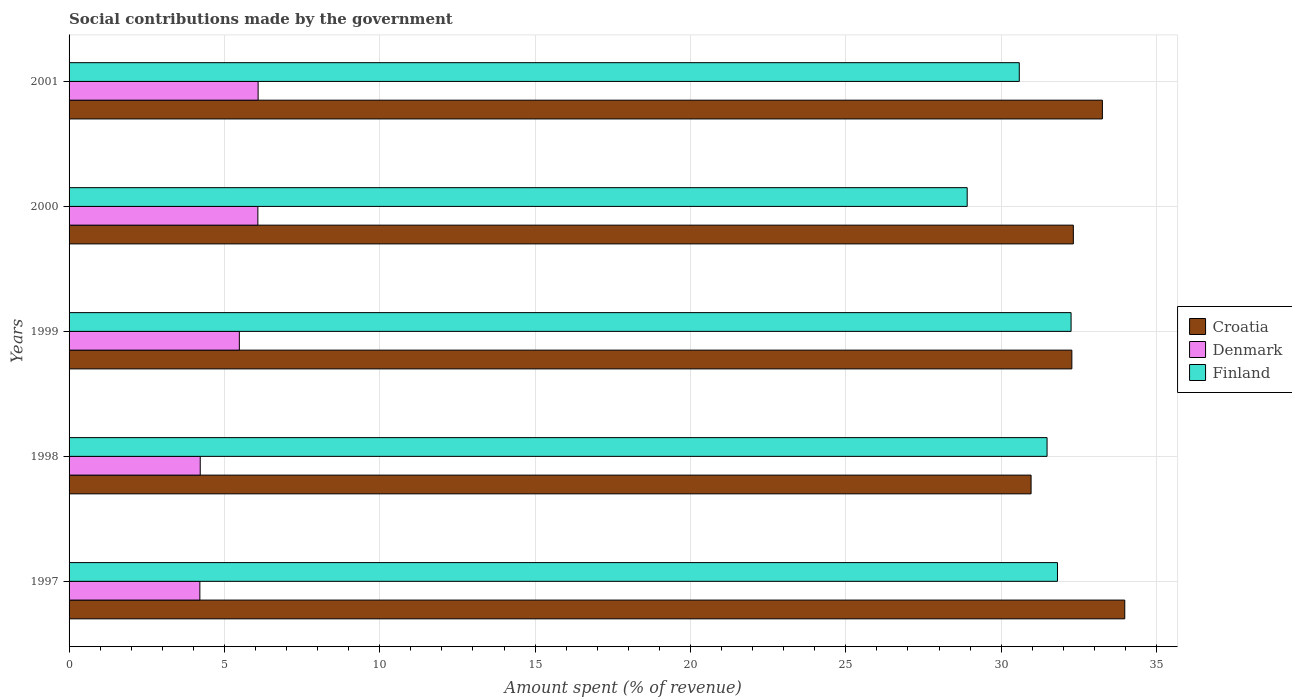How many different coloured bars are there?
Provide a short and direct response. 3. Are the number of bars on each tick of the Y-axis equal?
Give a very brief answer. Yes. How many bars are there on the 4th tick from the top?
Your answer should be very brief. 3. How many bars are there on the 2nd tick from the bottom?
Offer a very short reply. 3. What is the amount spent (in %) on social contributions in Croatia in 1999?
Give a very brief answer. 32.27. Across all years, what is the maximum amount spent (in %) on social contributions in Denmark?
Make the answer very short. 6.08. Across all years, what is the minimum amount spent (in %) on social contributions in Denmark?
Your answer should be compact. 4.21. In which year was the amount spent (in %) on social contributions in Croatia minimum?
Your answer should be compact. 1998. What is the total amount spent (in %) on social contributions in Denmark in the graph?
Ensure brevity in your answer.  26.07. What is the difference between the amount spent (in %) on social contributions in Croatia in 1997 and that in 2000?
Your answer should be compact. 1.66. What is the difference between the amount spent (in %) on social contributions in Croatia in 2000 and the amount spent (in %) on social contributions in Denmark in 1997?
Offer a very short reply. 28.11. What is the average amount spent (in %) on social contributions in Finland per year?
Provide a short and direct response. 31. In the year 1998, what is the difference between the amount spent (in %) on social contributions in Croatia and amount spent (in %) on social contributions in Finland?
Keep it short and to the point. -0.51. In how many years, is the amount spent (in %) on social contributions in Denmark greater than 7 %?
Your response must be concise. 0. What is the ratio of the amount spent (in %) on social contributions in Denmark in 1998 to that in 2001?
Offer a terse response. 0.69. Is the difference between the amount spent (in %) on social contributions in Croatia in 1997 and 2001 greater than the difference between the amount spent (in %) on social contributions in Finland in 1997 and 2001?
Provide a succinct answer. No. What is the difference between the highest and the second highest amount spent (in %) on social contributions in Denmark?
Your answer should be very brief. 0.01. What is the difference between the highest and the lowest amount spent (in %) on social contributions in Croatia?
Provide a succinct answer. 3.02. In how many years, is the amount spent (in %) on social contributions in Croatia greater than the average amount spent (in %) on social contributions in Croatia taken over all years?
Your response must be concise. 2. What does the 2nd bar from the top in 2000 represents?
Your answer should be compact. Denmark. What does the 1st bar from the bottom in 1997 represents?
Ensure brevity in your answer.  Croatia. How many bars are there?
Your response must be concise. 15. How many years are there in the graph?
Offer a terse response. 5. What is the difference between two consecutive major ticks on the X-axis?
Offer a terse response. 5. Are the values on the major ticks of X-axis written in scientific E-notation?
Provide a short and direct response. No. Does the graph contain any zero values?
Your answer should be very brief. No. How many legend labels are there?
Provide a succinct answer. 3. How are the legend labels stacked?
Your response must be concise. Vertical. What is the title of the graph?
Keep it short and to the point. Social contributions made by the government. What is the label or title of the X-axis?
Provide a succinct answer. Amount spent (% of revenue). What is the label or title of the Y-axis?
Provide a short and direct response. Years. What is the Amount spent (% of revenue) in Croatia in 1997?
Offer a very short reply. 33.98. What is the Amount spent (% of revenue) in Denmark in 1997?
Offer a terse response. 4.21. What is the Amount spent (% of revenue) in Finland in 1997?
Your answer should be compact. 31.81. What is the Amount spent (% of revenue) of Croatia in 1998?
Provide a short and direct response. 30.96. What is the Amount spent (% of revenue) in Denmark in 1998?
Your answer should be very brief. 4.22. What is the Amount spent (% of revenue) in Finland in 1998?
Ensure brevity in your answer.  31.48. What is the Amount spent (% of revenue) of Croatia in 1999?
Keep it short and to the point. 32.27. What is the Amount spent (% of revenue) of Denmark in 1999?
Give a very brief answer. 5.48. What is the Amount spent (% of revenue) of Finland in 1999?
Give a very brief answer. 32.25. What is the Amount spent (% of revenue) of Croatia in 2000?
Your answer should be compact. 32.32. What is the Amount spent (% of revenue) of Denmark in 2000?
Your answer should be compact. 6.08. What is the Amount spent (% of revenue) of Finland in 2000?
Your response must be concise. 28.91. What is the Amount spent (% of revenue) of Croatia in 2001?
Keep it short and to the point. 33.26. What is the Amount spent (% of revenue) of Denmark in 2001?
Give a very brief answer. 6.08. What is the Amount spent (% of revenue) of Finland in 2001?
Keep it short and to the point. 30.58. Across all years, what is the maximum Amount spent (% of revenue) of Croatia?
Ensure brevity in your answer.  33.98. Across all years, what is the maximum Amount spent (% of revenue) of Denmark?
Offer a terse response. 6.08. Across all years, what is the maximum Amount spent (% of revenue) of Finland?
Keep it short and to the point. 32.25. Across all years, what is the minimum Amount spent (% of revenue) of Croatia?
Provide a succinct answer. 30.96. Across all years, what is the minimum Amount spent (% of revenue) of Denmark?
Give a very brief answer. 4.21. Across all years, what is the minimum Amount spent (% of revenue) in Finland?
Make the answer very short. 28.91. What is the total Amount spent (% of revenue) in Croatia in the graph?
Offer a terse response. 162.79. What is the total Amount spent (% of revenue) of Denmark in the graph?
Provide a succinct answer. 26.07. What is the total Amount spent (% of revenue) of Finland in the graph?
Provide a short and direct response. 155.02. What is the difference between the Amount spent (% of revenue) in Croatia in 1997 and that in 1998?
Provide a short and direct response. 3.02. What is the difference between the Amount spent (% of revenue) of Denmark in 1997 and that in 1998?
Give a very brief answer. -0.01. What is the difference between the Amount spent (% of revenue) of Finland in 1997 and that in 1998?
Your answer should be very brief. 0.34. What is the difference between the Amount spent (% of revenue) of Croatia in 1997 and that in 1999?
Your answer should be compact. 1.7. What is the difference between the Amount spent (% of revenue) in Denmark in 1997 and that in 1999?
Make the answer very short. -1.27. What is the difference between the Amount spent (% of revenue) of Finland in 1997 and that in 1999?
Make the answer very short. -0.44. What is the difference between the Amount spent (% of revenue) in Croatia in 1997 and that in 2000?
Your response must be concise. 1.66. What is the difference between the Amount spent (% of revenue) of Denmark in 1997 and that in 2000?
Keep it short and to the point. -1.87. What is the difference between the Amount spent (% of revenue) of Finland in 1997 and that in 2000?
Offer a terse response. 2.91. What is the difference between the Amount spent (% of revenue) in Croatia in 1997 and that in 2001?
Your answer should be very brief. 0.72. What is the difference between the Amount spent (% of revenue) of Denmark in 1997 and that in 2001?
Offer a very short reply. -1.88. What is the difference between the Amount spent (% of revenue) in Finland in 1997 and that in 2001?
Keep it short and to the point. 1.23. What is the difference between the Amount spent (% of revenue) of Croatia in 1998 and that in 1999?
Keep it short and to the point. -1.31. What is the difference between the Amount spent (% of revenue) in Denmark in 1998 and that in 1999?
Ensure brevity in your answer.  -1.26. What is the difference between the Amount spent (% of revenue) in Finland in 1998 and that in 1999?
Keep it short and to the point. -0.77. What is the difference between the Amount spent (% of revenue) in Croatia in 1998 and that in 2000?
Make the answer very short. -1.36. What is the difference between the Amount spent (% of revenue) of Denmark in 1998 and that in 2000?
Make the answer very short. -1.86. What is the difference between the Amount spent (% of revenue) in Finland in 1998 and that in 2000?
Your response must be concise. 2.57. What is the difference between the Amount spent (% of revenue) of Croatia in 1998 and that in 2001?
Give a very brief answer. -2.3. What is the difference between the Amount spent (% of revenue) of Denmark in 1998 and that in 2001?
Provide a short and direct response. -1.86. What is the difference between the Amount spent (% of revenue) of Finland in 1998 and that in 2001?
Give a very brief answer. 0.89. What is the difference between the Amount spent (% of revenue) of Croatia in 1999 and that in 2000?
Offer a very short reply. -0.05. What is the difference between the Amount spent (% of revenue) of Denmark in 1999 and that in 2000?
Give a very brief answer. -0.6. What is the difference between the Amount spent (% of revenue) in Finland in 1999 and that in 2000?
Provide a succinct answer. 3.34. What is the difference between the Amount spent (% of revenue) in Croatia in 1999 and that in 2001?
Your answer should be very brief. -0.98. What is the difference between the Amount spent (% of revenue) in Denmark in 1999 and that in 2001?
Give a very brief answer. -0.6. What is the difference between the Amount spent (% of revenue) in Finland in 1999 and that in 2001?
Offer a terse response. 1.67. What is the difference between the Amount spent (% of revenue) in Croatia in 2000 and that in 2001?
Give a very brief answer. -0.94. What is the difference between the Amount spent (% of revenue) in Denmark in 2000 and that in 2001?
Your answer should be very brief. -0.01. What is the difference between the Amount spent (% of revenue) of Finland in 2000 and that in 2001?
Your response must be concise. -1.68. What is the difference between the Amount spent (% of revenue) of Croatia in 1997 and the Amount spent (% of revenue) of Denmark in 1998?
Provide a succinct answer. 29.76. What is the difference between the Amount spent (% of revenue) in Croatia in 1997 and the Amount spent (% of revenue) in Finland in 1998?
Keep it short and to the point. 2.5. What is the difference between the Amount spent (% of revenue) in Denmark in 1997 and the Amount spent (% of revenue) in Finland in 1998?
Ensure brevity in your answer.  -27.27. What is the difference between the Amount spent (% of revenue) in Croatia in 1997 and the Amount spent (% of revenue) in Denmark in 1999?
Provide a succinct answer. 28.5. What is the difference between the Amount spent (% of revenue) in Croatia in 1997 and the Amount spent (% of revenue) in Finland in 1999?
Your response must be concise. 1.73. What is the difference between the Amount spent (% of revenue) in Denmark in 1997 and the Amount spent (% of revenue) in Finland in 1999?
Provide a short and direct response. -28.04. What is the difference between the Amount spent (% of revenue) of Croatia in 1997 and the Amount spent (% of revenue) of Denmark in 2000?
Make the answer very short. 27.9. What is the difference between the Amount spent (% of revenue) of Croatia in 1997 and the Amount spent (% of revenue) of Finland in 2000?
Your response must be concise. 5.07. What is the difference between the Amount spent (% of revenue) of Denmark in 1997 and the Amount spent (% of revenue) of Finland in 2000?
Offer a very short reply. -24.7. What is the difference between the Amount spent (% of revenue) in Croatia in 1997 and the Amount spent (% of revenue) in Denmark in 2001?
Keep it short and to the point. 27.89. What is the difference between the Amount spent (% of revenue) in Croatia in 1997 and the Amount spent (% of revenue) in Finland in 2001?
Your answer should be compact. 3.4. What is the difference between the Amount spent (% of revenue) in Denmark in 1997 and the Amount spent (% of revenue) in Finland in 2001?
Your response must be concise. -26.37. What is the difference between the Amount spent (% of revenue) in Croatia in 1998 and the Amount spent (% of revenue) in Denmark in 1999?
Your answer should be compact. 25.48. What is the difference between the Amount spent (% of revenue) of Croatia in 1998 and the Amount spent (% of revenue) of Finland in 1999?
Provide a succinct answer. -1.29. What is the difference between the Amount spent (% of revenue) of Denmark in 1998 and the Amount spent (% of revenue) of Finland in 1999?
Ensure brevity in your answer.  -28.03. What is the difference between the Amount spent (% of revenue) of Croatia in 1998 and the Amount spent (% of revenue) of Denmark in 2000?
Offer a very short reply. 24.89. What is the difference between the Amount spent (% of revenue) in Croatia in 1998 and the Amount spent (% of revenue) in Finland in 2000?
Your answer should be very brief. 2.06. What is the difference between the Amount spent (% of revenue) in Denmark in 1998 and the Amount spent (% of revenue) in Finland in 2000?
Provide a short and direct response. -24.68. What is the difference between the Amount spent (% of revenue) of Croatia in 1998 and the Amount spent (% of revenue) of Denmark in 2001?
Keep it short and to the point. 24.88. What is the difference between the Amount spent (% of revenue) of Croatia in 1998 and the Amount spent (% of revenue) of Finland in 2001?
Offer a terse response. 0.38. What is the difference between the Amount spent (% of revenue) in Denmark in 1998 and the Amount spent (% of revenue) in Finland in 2001?
Your answer should be compact. -26.36. What is the difference between the Amount spent (% of revenue) of Croatia in 1999 and the Amount spent (% of revenue) of Denmark in 2000?
Offer a terse response. 26.2. What is the difference between the Amount spent (% of revenue) of Croatia in 1999 and the Amount spent (% of revenue) of Finland in 2000?
Give a very brief answer. 3.37. What is the difference between the Amount spent (% of revenue) in Denmark in 1999 and the Amount spent (% of revenue) in Finland in 2000?
Make the answer very short. -23.43. What is the difference between the Amount spent (% of revenue) of Croatia in 1999 and the Amount spent (% of revenue) of Denmark in 2001?
Your response must be concise. 26.19. What is the difference between the Amount spent (% of revenue) of Croatia in 1999 and the Amount spent (% of revenue) of Finland in 2001?
Provide a short and direct response. 1.69. What is the difference between the Amount spent (% of revenue) in Denmark in 1999 and the Amount spent (% of revenue) in Finland in 2001?
Provide a short and direct response. -25.1. What is the difference between the Amount spent (% of revenue) of Croatia in 2000 and the Amount spent (% of revenue) of Denmark in 2001?
Make the answer very short. 26.24. What is the difference between the Amount spent (% of revenue) of Croatia in 2000 and the Amount spent (% of revenue) of Finland in 2001?
Provide a short and direct response. 1.74. What is the difference between the Amount spent (% of revenue) of Denmark in 2000 and the Amount spent (% of revenue) of Finland in 2001?
Keep it short and to the point. -24.51. What is the average Amount spent (% of revenue) in Croatia per year?
Provide a succinct answer. 32.56. What is the average Amount spent (% of revenue) of Denmark per year?
Offer a very short reply. 5.21. What is the average Amount spent (% of revenue) of Finland per year?
Offer a very short reply. 31. In the year 1997, what is the difference between the Amount spent (% of revenue) in Croatia and Amount spent (% of revenue) in Denmark?
Provide a succinct answer. 29.77. In the year 1997, what is the difference between the Amount spent (% of revenue) of Croatia and Amount spent (% of revenue) of Finland?
Offer a terse response. 2.17. In the year 1997, what is the difference between the Amount spent (% of revenue) in Denmark and Amount spent (% of revenue) in Finland?
Make the answer very short. -27.6. In the year 1998, what is the difference between the Amount spent (% of revenue) of Croatia and Amount spent (% of revenue) of Denmark?
Your answer should be compact. 26.74. In the year 1998, what is the difference between the Amount spent (% of revenue) of Croatia and Amount spent (% of revenue) of Finland?
Keep it short and to the point. -0.51. In the year 1998, what is the difference between the Amount spent (% of revenue) in Denmark and Amount spent (% of revenue) in Finland?
Give a very brief answer. -27.25. In the year 1999, what is the difference between the Amount spent (% of revenue) of Croatia and Amount spent (% of revenue) of Denmark?
Your answer should be compact. 26.79. In the year 1999, what is the difference between the Amount spent (% of revenue) in Croatia and Amount spent (% of revenue) in Finland?
Your response must be concise. 0.03. In the year 1999, what is the difference between the Amount spent (% of revenue) in Denmark and Amount spent (% of revenue) in Finland?
Provide a short and direct response. -26.77. In the year 2000, what is the difference between the Amount spent (% of revenue) in Croatia and Amount spent (% of revenue) in Denmark?
Give a very brief answer. 26.25. In the year 2000, what is the difference between the Amount spent (% of revenue) in Croatia and Amount spent (% of revenue) in Finland?
Keep it short and to the point. 3.42. In the year 2000, what is the difference between the Amount spent (% of revenue) in Denmark and Amount spent (% of revenue) in Finland?
Your response must be concise. -22.83. In the year 2001, what is the difference between the Amount spent (% of revenue) of Croatia and Amount spent (% of revenue) of Denmark?
Provide a succinct answer. 27.17. In the year 2001, what is the difference between the Amount spent (% of revenue) in Croatia and Amount spent (% of revenue) in Finland?
Keep it short and to the point. 2.67. In the year 2001, what is the difference between the Amount spent (% of revenue) of Denmark and Amount spent (% of revenue) of Finland?
Give a very brief answer. -24.5. What is the ratio of the Amount spent (% of revenue) of Croatia in 1997 to that in 1998?
Offer a terse response. 1.1. What is the ratio of the Amount spent (% of revenue) in Denmark in 1997 to that in 1998?
Offer a very short reply. 1. What is the ratio of the Amount spent (% of revenue) of Finland in 1997 to that in 1998?
Keep it short and to the point. 1.01. What is the ratio of the Amount spent (% of revenue) of Croatia in 1997 to that in 1999?
Offer a very short reply. 1.05. What is the ratio of the Amount spent (% of revenue) of Denmark in 1997 to that in 1999?
Your answer should be very brief. 0.77. What is the ratio of the Amount spent (% of revenue) in Finland in 1997 to that in 1999?
Provide a short and direct response. 0.99. What is the ratio of the Amount spent (% of revenue) of Croatia in 1997 to that in 2000?
Keep it short and to the point. 1.05. What is the ratio of the Amount spent (% of revenue) of Denmark in 1997 to that in 2000?
Give a very brief answer. 0.69. What is the ratio of the Amount spent (% of revenue) of Finland in 1997 to that in 2000?
Your answer should be very brief. 1.1. What is the ratio of the Amount spent (% of revenue) in Croatia in 1997 to that in 2001?
Keep it short and to the point. 1.02. What is the ratio of the Amount spent (% of revenue) of Denmark in 1997 to that in 2001?
Offer a terse response. 0.69. What is the ratio of the Amount spent (% of revenue) of Finland in 1997 to that in 2001?
Give a very brief answer. 1.04. What is the ratio of the Amount spent (% of revenue) in Croatia in 1998 to that in 1999?
Offer a terse response. 0.96. What is the ratio of the Amount spent (% of revenue) in Denmark in 1998 to that in 1999?
Offer a very short reply. 0.77. What is the ratio of the Amount spent (% of revenue) of Finland in 1998 to that in 1999?
Make the answer very short. 0.98. What is the ratio of the Amount spent (% of revenue) in Croatia in 1998 to that in 2000?
Keep it short and to the point. 0.96. What is the ratio of the Amount spent (% of revenue) in Denmark in 1998 to that in 2000?
Ensure brevity in your answer.  0.69. What is the ratio of the Amount spent (% of revenue) in Finland in 1998 to that in 2000?
Provide a short and direct response. 1.09. What is the ratio of the Amount spent (% of revenue) of Denmark in 1998 to that in 2001?
Offer a very short reply. 0.69. What is the ratio of the Amount spent (% of revenue) in Finland in 1998 to that in 2001?
Offer a very short reply. 1.03. What is the ratio of the Amount spent (% of revenue) in Croatia in 1999 to that in 2000?
Your response must be concise. 1. What is the ratio of the Amount spent (% of revenue) in Denmark in 1999 to that in 2000?
Your answer should be very brief. 0.9. What is the ratio of the Amount spent (% of revenue) of Finland in 1999 to that in 2000?
Give a very brief answer. 1.12. What is the ratio of the Amount spent (% of revenue) in Croatia in 1999 to that in 2001?
Provide a succinct answer. 0.97. What is the ratio of the Amount spent (% of revenue) of Denmark in 1999 to that in 2001?
Make the answer very short. 0.9. What is the ratio of the Amount spent (% of revenue) of Finland in 1999 to that in 2001?
Make the answer very short. 1.05. What is the ratio of the Amount spent (% of revenue) in Croatia in 2000 to that in 2001?
Offer a terse response. 0.97. What is the ratio of the Amount spent (% of revenue) of Finland in 2000 to that in 2001?
Provide a short and direct response. 0.95. What is the difference between the highest and the second highest Amount spent (% of revenue) in Croatia?
Offer a very short reply. 0.72. What is the difference between the highest and the second highest Amount spent (% of revenue) in Denmark?
Make the answer very short. 0.01. What is the difference between the highest and the second highest Amount spent (% of revenue) in Finland?
Provide a short and direct response. 0.44. What is the difference between the highest and the lowest Amount spent (% of revenue) of Croatia?
Offer a terse response. 3.02. What is the difference between the highest and the lowest Amount spent (% of revenue) in Denmark?
Your answer should be very brief. 1.88. What is the difference between the highest and the lowest Amount spent (% of revenue) of Finland?
Provide a succinct answer. 3.34. 